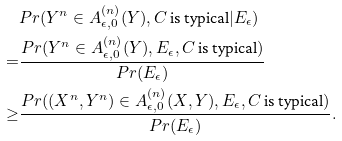Convert formula to latex. <formula><loc_0><loc_0><loc_500><loc_500>& P r ( Y ^ { n } \in A _ { \epsilon , 0 } ^ { ( n ) } ( Y ) , C \text { is typical} | E _ { \epsilon } ) \\ = & \frac { P r ( Y ^ { n } \in A _ { \epsilon , 0 } ^ { ( n ) } ( Y ) , E _ { \epsilon } , C \text { is typical} ) } { P r ( E _ { \epsilon } ) } \\ \geq & \frac { P r ( ( X ^ { n } , Y ^ { n } ) \in A _ { \epsilon , 0 } ^ { ( n ) } ( X , Y ) , E _ { \epsilon } , C \text { is typical} ) } { P r ( E _ { \epsilon } ) } .</formula> 